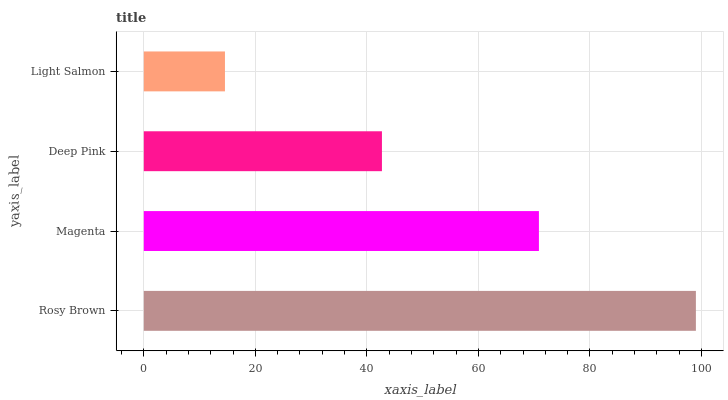Is Light Salmon the minimum?
Answer yes or no. Yes. Is Rosy Brown the maximum?
Answer yes or no. Yes. Is Magenta the minimum?
Answer yes or no. No. Is Magenta the maximum?
Answer yes or no. No. Is Rosy Brown greater than Magenta?
Answer yes or no. Yes. Is Magenta less than Rosy Brown?
Answer yes or no. Yes. Is Magenta greater than Rosy Brown?
Answer yes or no. No. Is Rosy Brown less than Magenta?
Answer yes or no. No. Is Magenta the high median?
Answer yes or no. Yes. Is Deep Pink the low median?
Answer yes or no. Yes. Is Deep Pink the high median?
Answer yes or no. No. Is Magenta the low median?
Answer yes or no. No. 